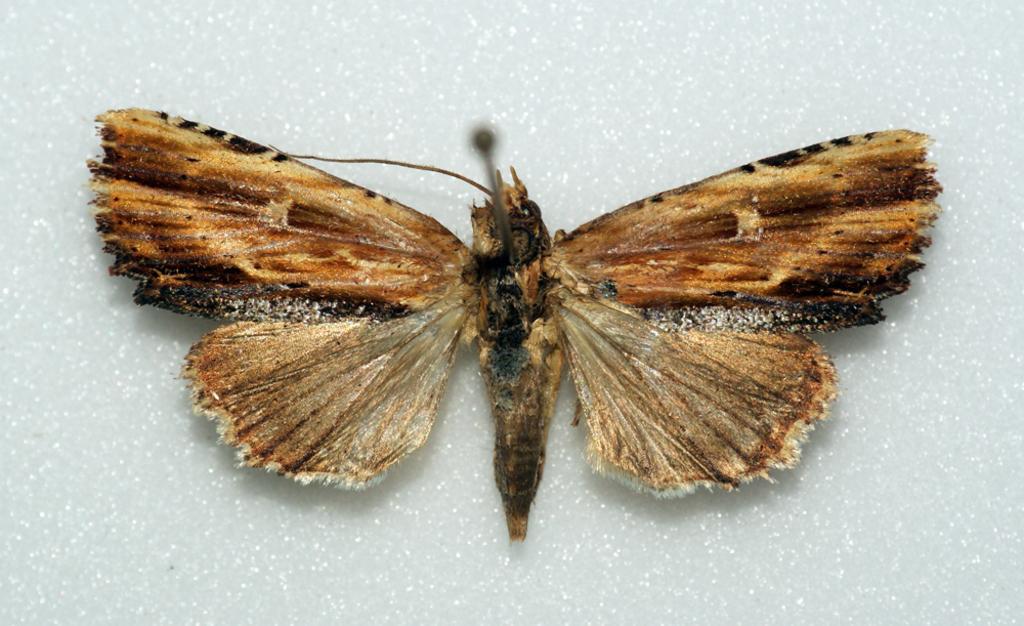Please provide a concise description of this image. In the center of the image we can see a butterfly is present on the wall. 